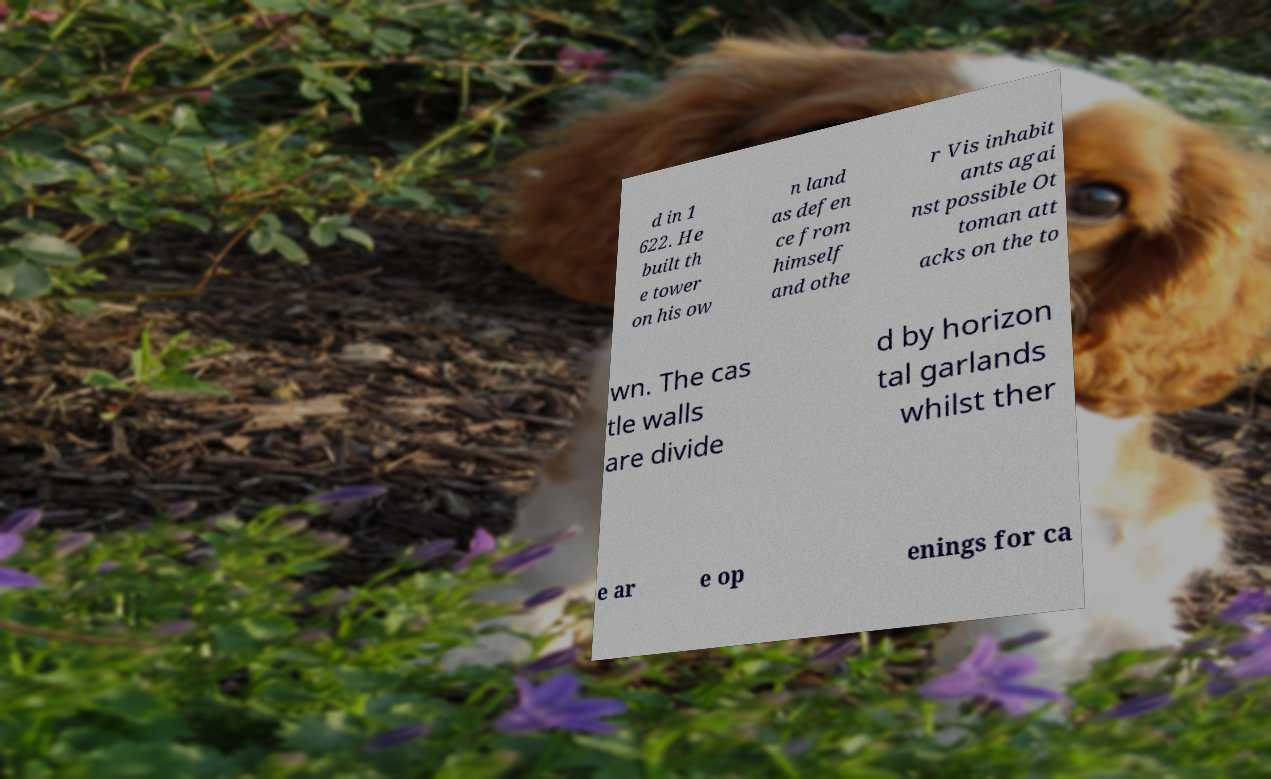Could you assist in decoding the text presented in this image and type it out clearly? d in 1 622. He built th e tower on his ow n land as defen ce from himself and othe r Vis inhabit ants agai nst possible Ot toman att acks on the to wn. The cas tle walls are divide d by horizon tal garlands whilst ther e ar e op enings for ca 